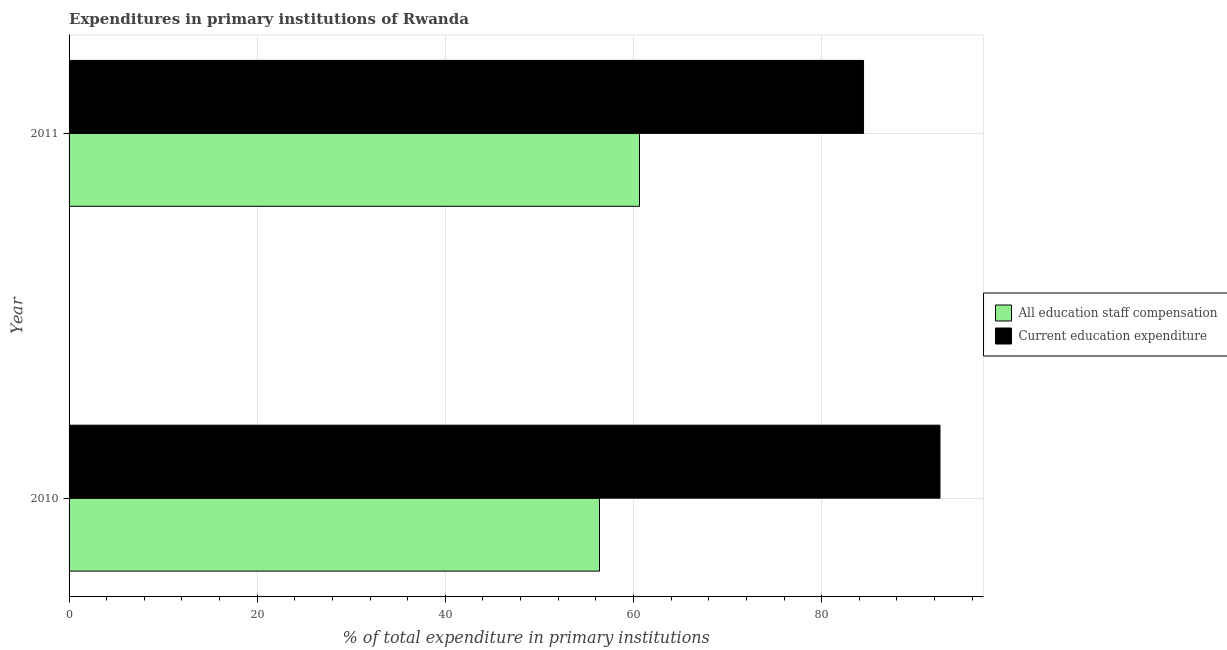How many different coloured bars are there?
Your response must be concise. 2. How many groups of bars are there?
Your answer should be compact. 2. Are the number of bars on each tick of the Y-axis equal?
Keep it short and to the point. Yes. How many bars are there on the 2nd tick from the bottom?
Offer a very short reply. 2. What is the expenditure in staff compensation in 2011?
Your answer should be very brief. 60.64. Across all years, what is the maximum expenditure in staff compensation?
Make the answer very short. 60.64. Across all years, what is the minimum expenditure in staff compensation?
Your response must be concise. 56.39. In which year was the expenditure in education maximum?
Provide a succinct answer. 2010. In which year was the expenditure in education minimum?
Offer a terse response. 2011. What is the total expenditure in education in the graph?
Keep it short and to the point. 177.03. What is the difference between the expenditure in education in 2010 and that in 2011?
Offer a terse response. 8.12. What is the difference between the expenditure in education in 2011 and the expenditure in staff compensation in 2010?
Your answer should be compact. 28.07. What is the average expenditure in staff compensation per year?
Make the answer very short. 58.51. In the year 2010, what is the difference between the expenditure in staff compensation and expenditure in education?
Offer a very short reply. -36.19. What is the ratio of the expenditure in education in 2010 to that in 2011?
Ensure brevity in your answer.  1.1. In how many years, is the expenditure in education greater than the average expenditure in education taken over all years?
Your answer should be compact. 1. What does the 2nd bar from the top in 2010 represents?
Your answer should be very brief. All education staff compensation. What does the 2nd bar from the bottom in 2010 represents?
Give a very brief answer. Current education expenditure. How many years are there in the graph?
Ensure brevity in your answer.  2. Where does the legend appear in the graph?
Give a very brief answer. Center right. What is the title of the graph?
Offer a terse response. Expenditures in primary institutions of Rwanda. What is the label or title of the X-axis?
Provide a short and direct response. % of total expenditure in primary institutions. What is the % of total expenditure in primary institutions in All education staff compensation in 2010?
Make the answer very short. 56.39. What is the % of total expenditure in primary institutions in Current education expenditure in 2010?
Your answer should be compact. 92.58. What is the % of total expenditure in primary institutions of All education staff compensation in 2011?
Your answer should be compact. 60.64. What is the % of total expenditure in primary institutions of Current education expenditure in 2011?
Your answer should be compact. 84.46. Across all years, what is the maximum % of total expenditure in primary institutions of All education staff compensation?
Ensure brevity in your answer.  60.64. Across all years, what is the maximum % of total expenditure in primary institutions in Current education expenditure?
Provide a short and direct response. 92.58. Across all years, what is the minimum % of total expenditure in primary institutions in All education staff compensation?
Keep it short and to the point. 56.39. Across all years, what is the minimum % of total expenditure in primary institutions in Current education expenditure?
Your response must be concise. 84.46. What is the total % of total expenditure in primary institutions in All education staff compensation in the graph?
Offer a very short reply. 117.02. What is the total % of total expenditure in primary institutions in Current education expenditure in the graph?
Your answer should be compact. 177.03. What is the difference between the % of total expenditure in primary institutions in All education staff compensation in 2010 and that in 2011?
Ensure brevity in your answer.  -4.25. What is the difference between the % of total expenditure in primary institutions in Current education expenditure in 2010 and that in 2011?
Ensure brevity in your answer.  8.12. What is the difference between the % of total expenditure in primary institutions in All education staff compensation in 2010 and the % of total expenditure in primary institutions in Current education expenditure in 2011?
Make the answer very short. -28.07. What is the average % of total expenditure in primary institutions in All education staff compensation per year?
Give a very brief answer. 58.51. What is the average % of total expenditure in primary institutions of Current education expenditure per year?
Your answer should be compact. 88.52. In the year 2010, what is the difference between the % of total expenditure in primary institutions in All education staff compensation and % of total expenditure in primary institutions in Current education expenditure?
Your response must be concise. -36.19. In the year 2011, what is the difference between the % of total expenditure in primary institutions of All education staff compensation and % of total expenditure in primary institutions of Current education expenditure?
Provide a short and direct response. -23.82. What is the ratio of the % of total expenditure in primary institutions in All education staff compensation in 2010 to that in 2011?
Your answer should be compact. 0.93. What is the ratio of the % of total expenditure in primary institutions of Current education expenditure in 2010 to that in 2011?
Your response must be concise. 1.1. What is the difference between the highest and the second highest % of total expenditure in primary institutions in All education staff compensation?
Make the answer very short. 4.25. What is the difference between the highest and the second highest % of total expenditure in primary institutions of Current education expenditure?
Provide a short and direct response. 8.12. What is the difference between the highest and the lowest % of total expenditure in primary institutions of All education staff compensation?
Your answer should be very brief. 4.25. What is the difference between the highest and the lowest % of total expenditure in primary institutions of Current education expenditure?
Provide a succinct answer. 8.12. 